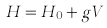<formula> <loc_0><loc_0><loc_500><loc_500>H = H _ { 0 } + g V</formula> 